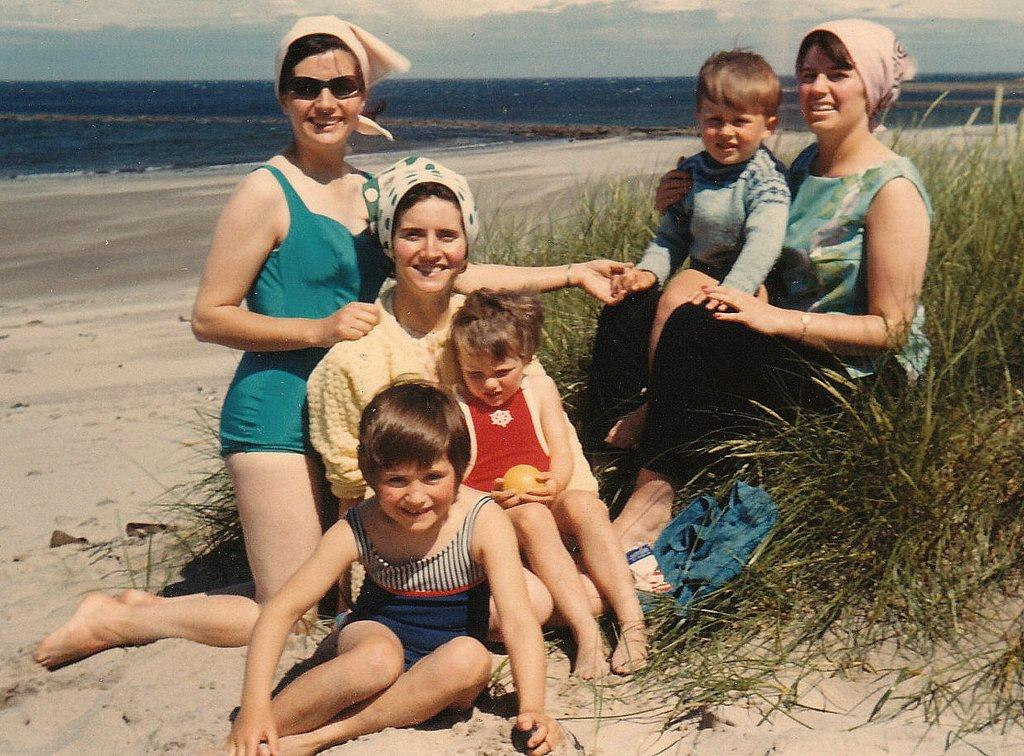How many people are in the foreground of the image? There are six persons in the foreground of the image. What is the surface on which the persons are standing? The persons are on grass. What can be seen in the background of the image? Water and the sky are visible in the background of the image. What type of environment might the image have been taken in? The image might have been taken on a sandy beach. What type of sign can be seen in the image? There is no sign present in the image. What is the color of the shoe worn by the person in the image? There is no shoe visible in the image, as the persons are on grass and not wearing any footwear. 